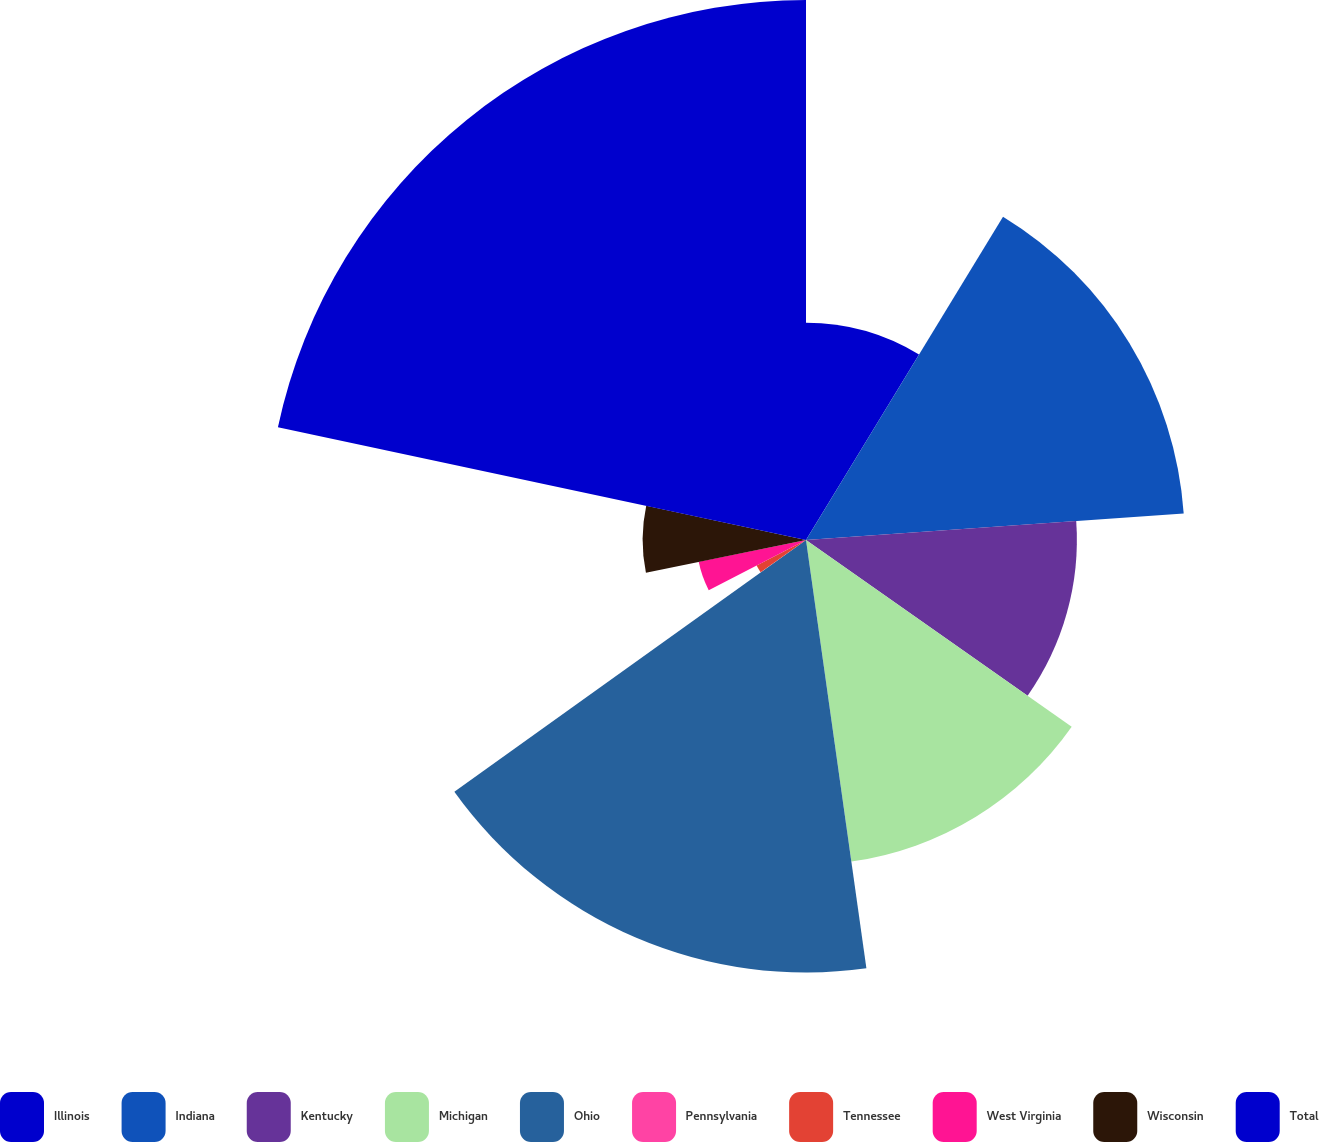Convert chart. <chart><loc_0><loc_0><loc_500><loc_500><pie_chart><fcel>Illinois<fcel>Indiana<fcel>Kentucky<fcel>Michigan<fcel>Ohio<fcel>Pennsylvania<fcel>Tennessee<fcel>West Virginia<fcel>Wisconsin<fcel>Total<nl><fcel>8.71%<fcel>15.18%<fcel>10.86%<fcel>13.02%<fcel>17.34%<fcel>0.07%<fcel>2.23%<fcel>4.39%<fcel>6.55%<fcel>21.65%<nl></chart> 